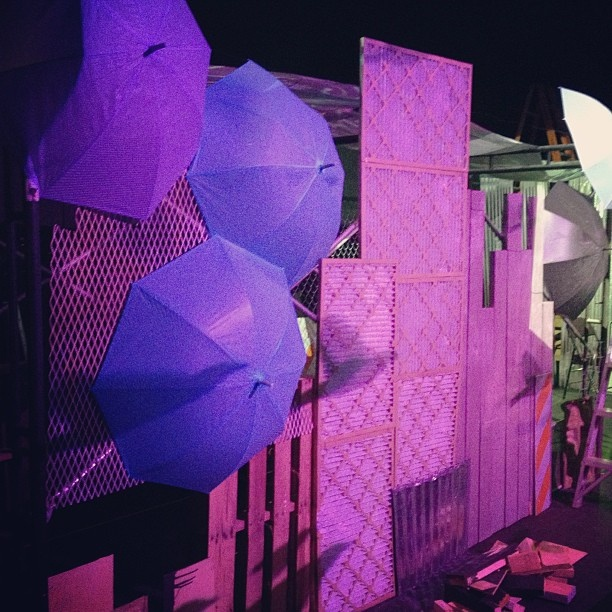Describe the objects in this image and their specific colors. I can see umbrella in black, magenta, blue, navy, and darkblue tones, umbrella in black, purple, navy, and blue tones, umbrella in black, magenta, and blue tones, umbrella in black, gray, pink, and darkgray tones, and umbrella in black, ivory, darkgray, and gray tones in this image. 